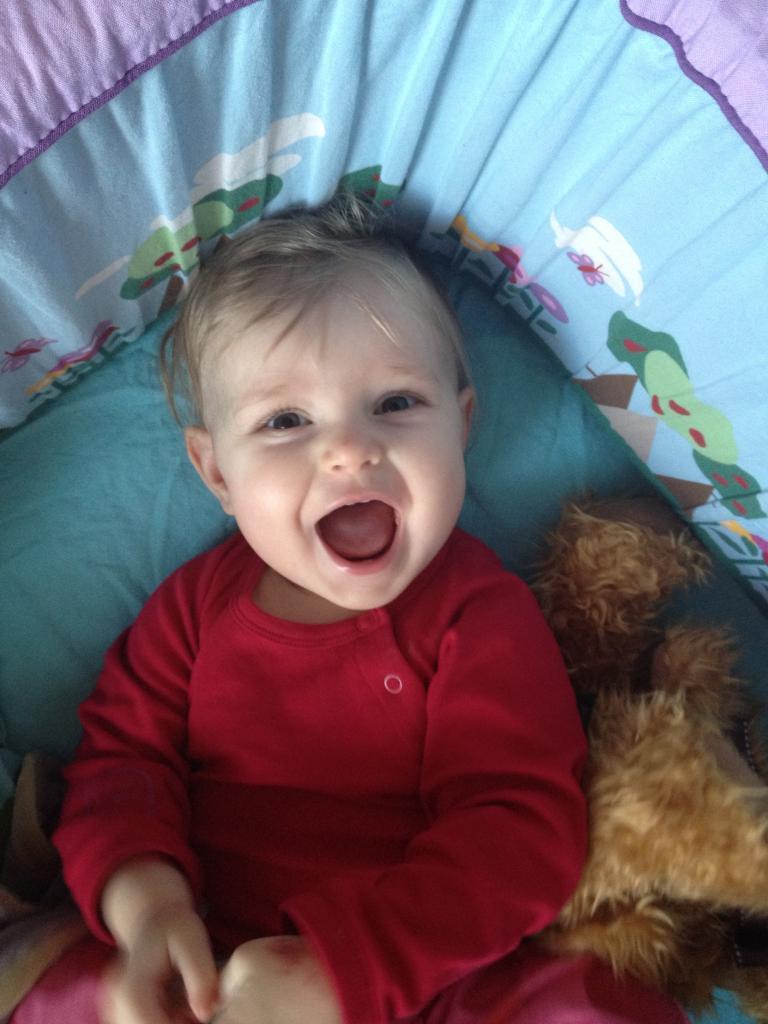Can you describe this image briefly? In this image I can see a person laying on the bed and smiling. 